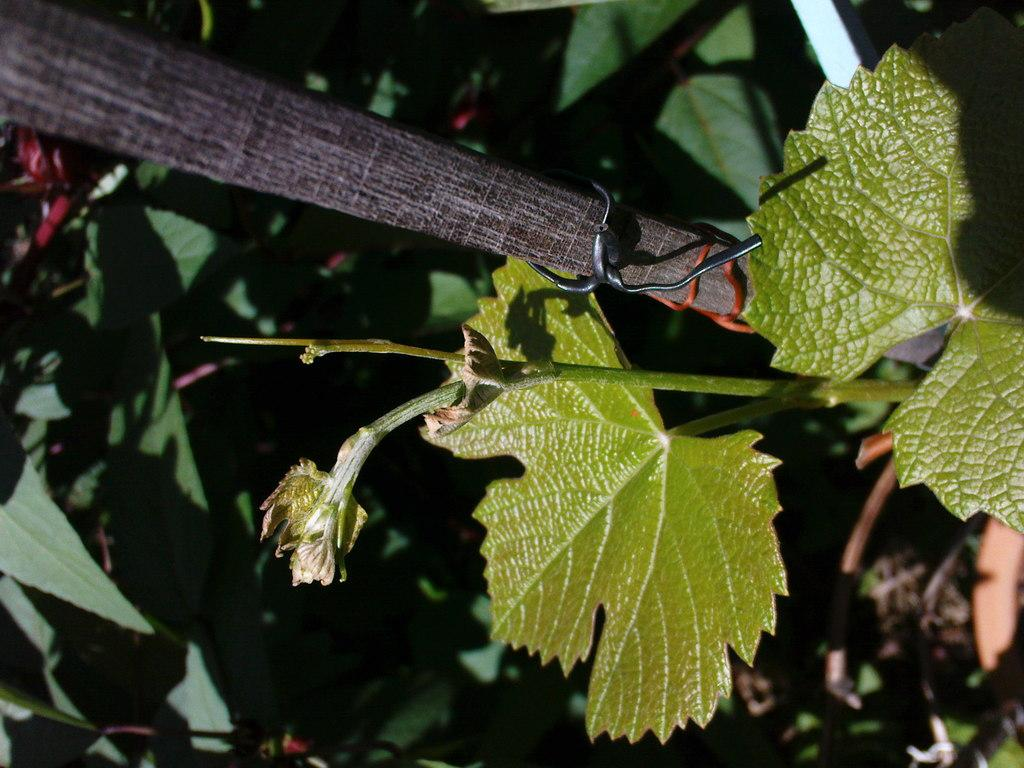What is present on the stem in the image? There is a bud on a stem in the image. What can be seen attached to an object in the image? There is a wire on an object in the image. What type of vegetation can be seen in the background of the image? There are plants visible in the background of the image. What color is the cap on the ant in the image? There is no ant or cap present in the image. What type of lead is being used by the object in the image? There is no mention of lead or any object using it in the image. 